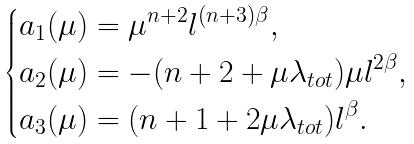<formula> <loc_0><loc_0><loc_500><loc_500>\begin{dcases} a _ { 1 } ( \mu ) = \mu ^ { n + 2 } l ^ { ( n + 3 ) \beta } , \\ a _ { 2 } ( \mu ) = - ( n + 2 + \mu \lambda _ { t o t } ) \mu l ^ { 2 \beta } , \\ a _ { 3 } ( \mu ) = ( n + 1 + 2 \mu \lambda _ { t o t } ) l ^ { \beta } . \end{dcases}</formula> 